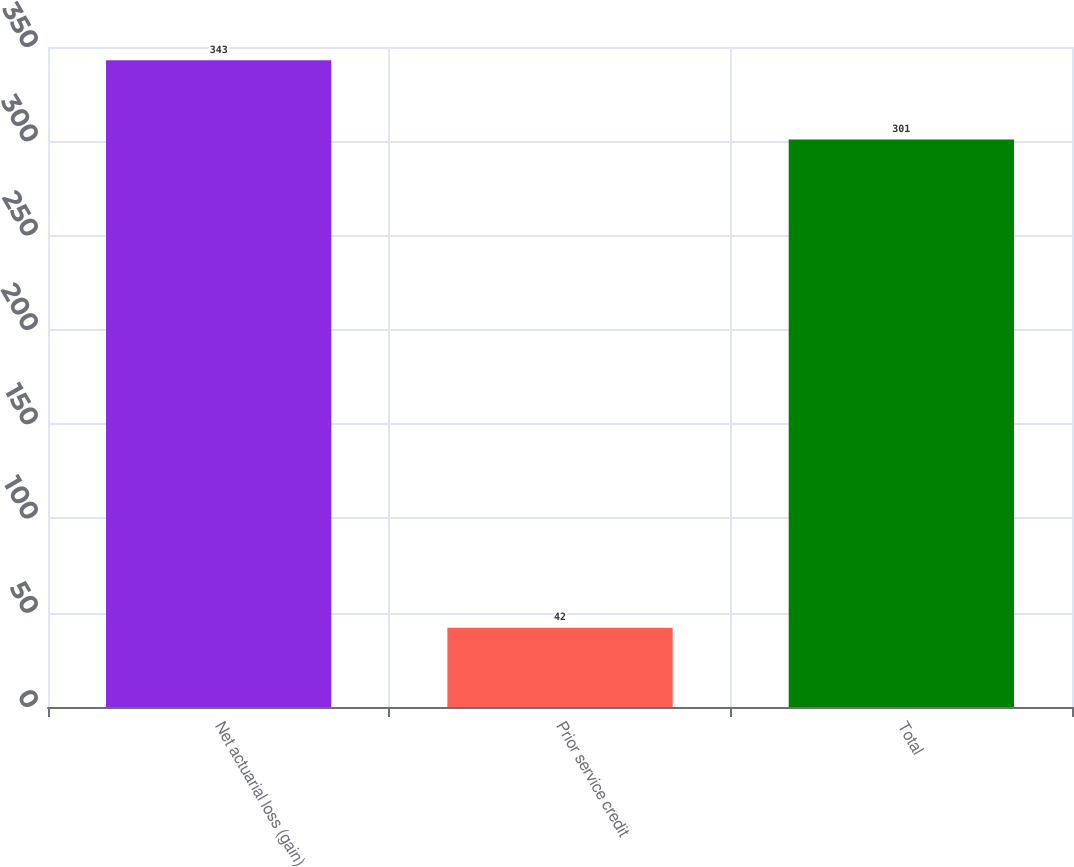Convert chart to OTSL. <chart><loc_0><loc_0><loc_500><loc_500><bar_chart><fcel>Net actuarial loss (gain)<fcel>Prior service credit<fcel>Total<nl><fcel>343<fcel>42<fcel>301<nl></chart> 